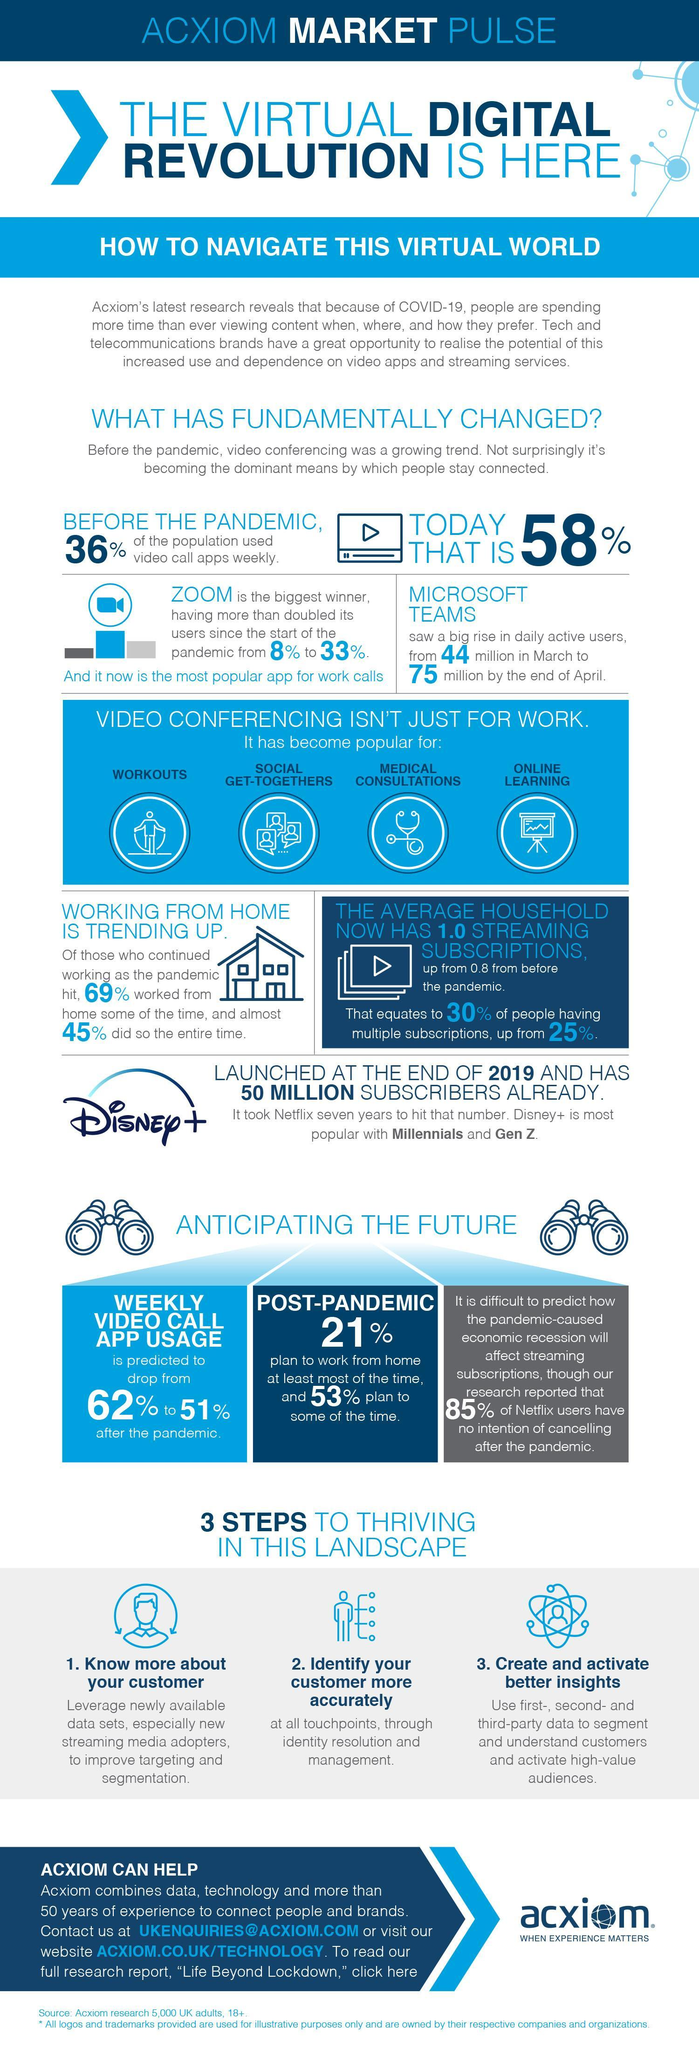What is the percentage increase in use of Microsoft teams app?
Answer the question with a short phrase. from 44 million in March to 75 million by the end of April Which is the application that has crossed Netflix within just one year after its launch? Disney+ What is the inverse percentage of people who worked from home for some of the time during pandemic? 31 What is the expecting drop percentage of video conferencing app post the pandemic? 62% to 51% Which is the current most used application for work calls? Zoom What percent of people are using video call apps in the current corona situation? 58% How can we identify our customer more accurately? through identity resolution and management How people are getting connected in this pandemic situation? video conferencing What is the inverse percentage of people who worked from home for entire time during pandemic? 55 In How many different fields other than work video conferencing can be used? 4 